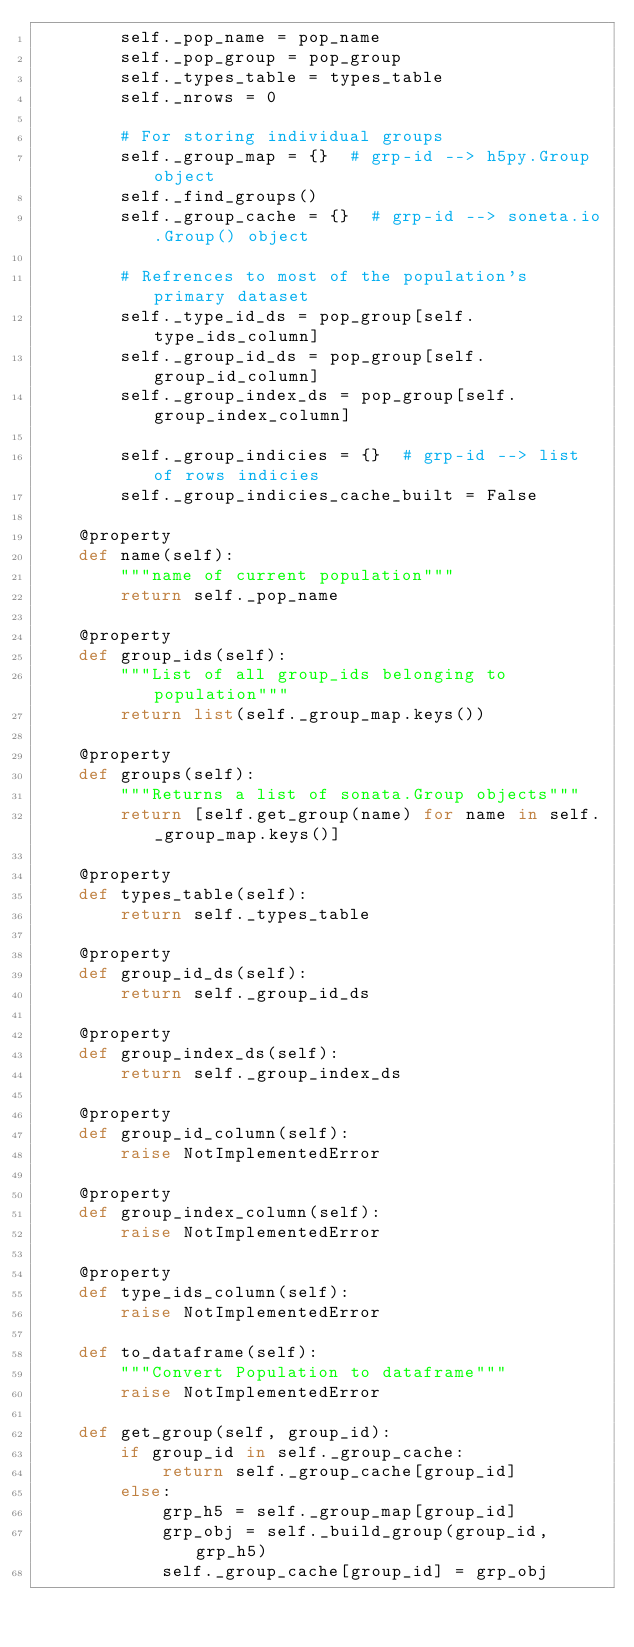Convert code to text. <code><loc_0><loc_0><loc_500><loc_500><_Python_>        self._pop_name = pop_name
        self._pop_group = pop_group
        self._types_table = types_table
        self._nrows = 0

        # For storing individual groups
        self._group_map = {}  # grp-id --> h5py.Group object
        self._find_groups()
        self._group_cache = {}  # grp-id --> soneta.io.Group() object

        # Refrences to most of the population's primary dataset
        self._type_id_ds = pop_group[self.type_ids_column]
        self._group_id_ds = pop_group[self.group_id_column]
        self._group_index_ds = pop_group[self.group_index_column]

        self._group_indicies = {}  # grp-id --> list of rows indicies
        self._group_indicies_cache_built = False

    @property
    def name(self):
        """name of current population"""
        return self._pop_name

    @property
    def group_ids(self):
        """List of all group_ids belonging to population"""
        return list(self._group_map.keys())

    @property
    def groups(self):
        """Returns a list of sonata.Group objects"""
        return [self.get_group(name) for name in self._group_map.keys()]

    @property
    def types_table(self):
        return self._types_table

    @property
    def group_id_ds(self):
        return self._group_id_ds

    @property
    def group_index_ds(self):
        return self._group_index_ds

    @property
    def group_id_column(self):
        raise NotImplementedError

    @property
    def group_index_column(self):
        raise NotImplementedError

    @property
    def type_ids_column(self):
        raise NotImplementedError

    def to_dataframe(self):
        """Convert Population to dataframe"""
        raise NotImplementedError

    def get_group(self, group_id):
        if group_id in self._group_cache:
            return self._group_cache[group_id]
        else:
            grp_h5 = self._group_map[group_id]
            grp_obj = self._build_group(group_id, grp_h5)
            self._group_cache[group_id] = grp_obj</code> 